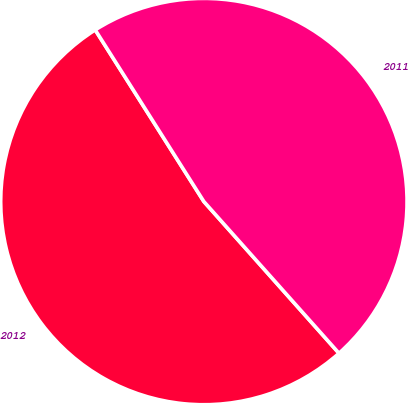Convert chart. <chart><loc_0><loc_0><loc_500><loc_500><pie_chart><fcel>2012<fcel>2011<nl><fcel>52.6%<fcel>47.4%<nl></chart> 